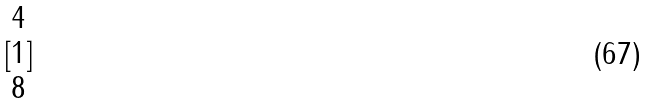<formula> <loc_0><loc_0><loc_500><loc_500>[ \begin{matrix} 4 \\ 1 \\ 8 \end{matrix} ]</formula> 